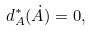<formula> <loc_0><loc_0><loc_500><loc_500>d _ { A } ^ { * } ( \dot { A } ) = 0 ,</formula> 